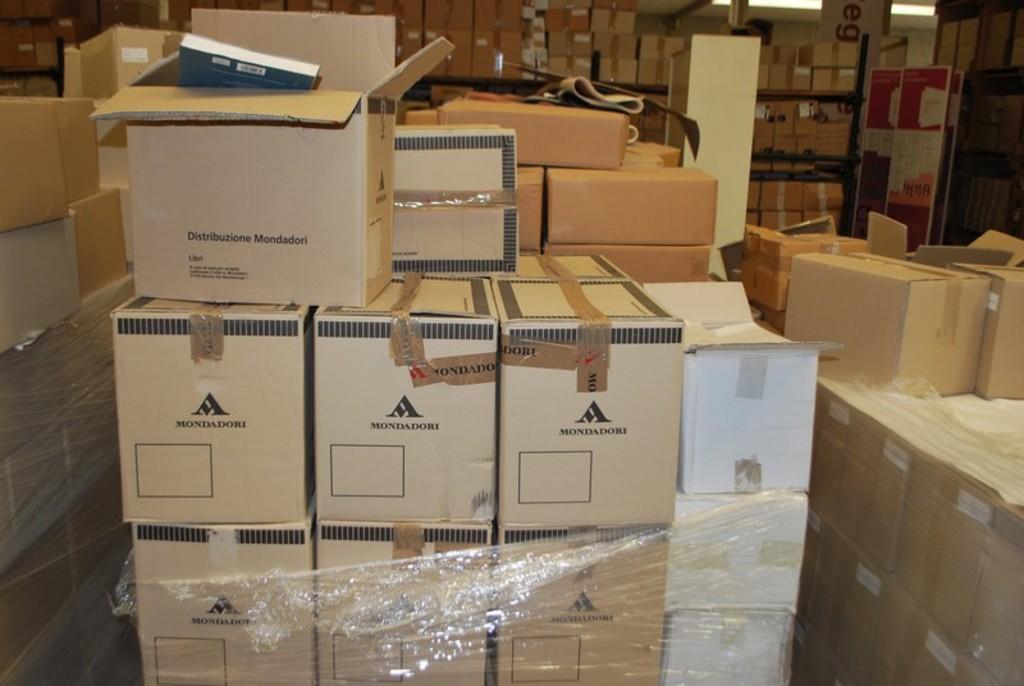What is inside the boxes?
Your answer should be compact. Mondadori. What is the name on the box?
Make the answer very short. Mondadori. 